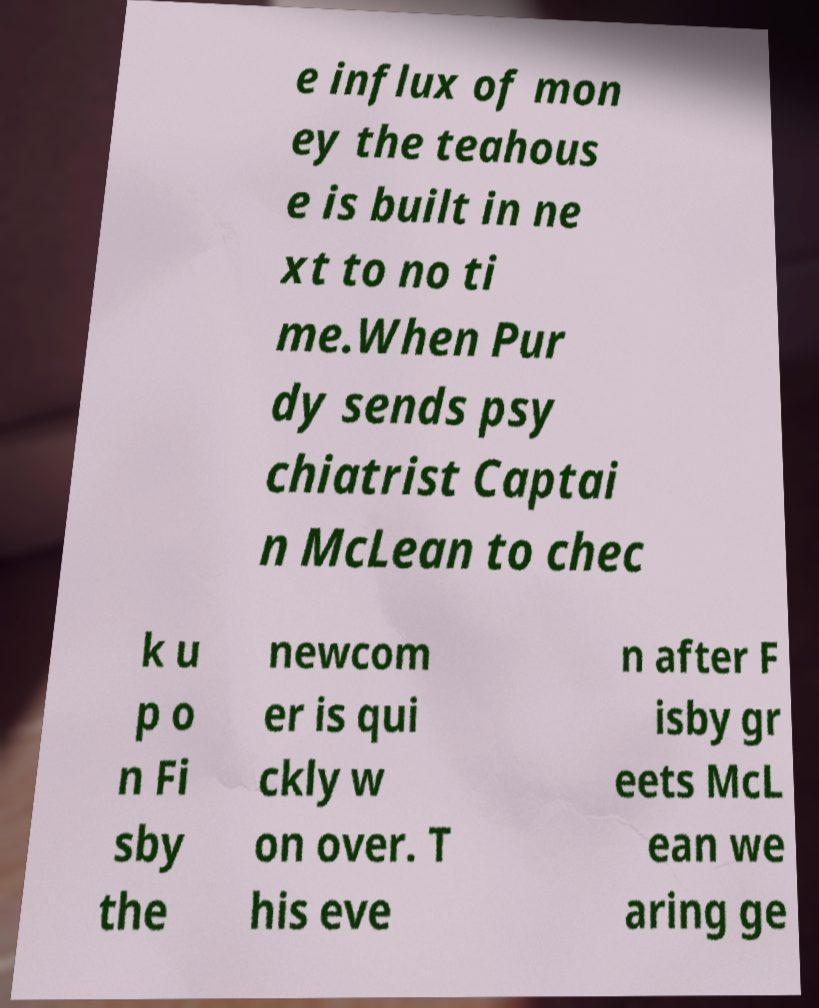Can you accurately transcribe the text from the provided image for me? e influx of mon ey the teahous e is built in ne xt to no ti me.When Pur dy sends psy chiatrist Captai n McLean to chec k u p o n Fi sby the newcom er is qui ckly w on over. T his eve n after F isby gr eets McL ean we aring ge 